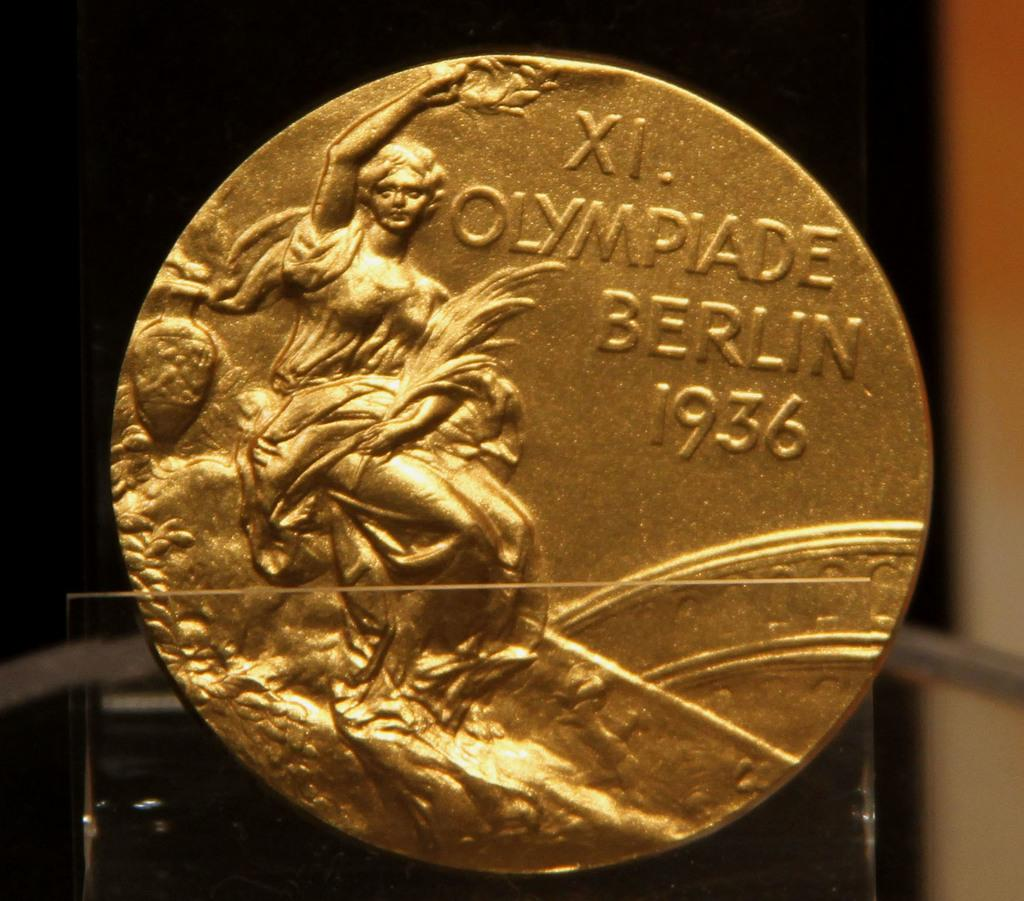<image>
Offer a succinct explanation of the picture presented. A 1936 Olympiade Berlin gold coin with the Greek number XI on it. 